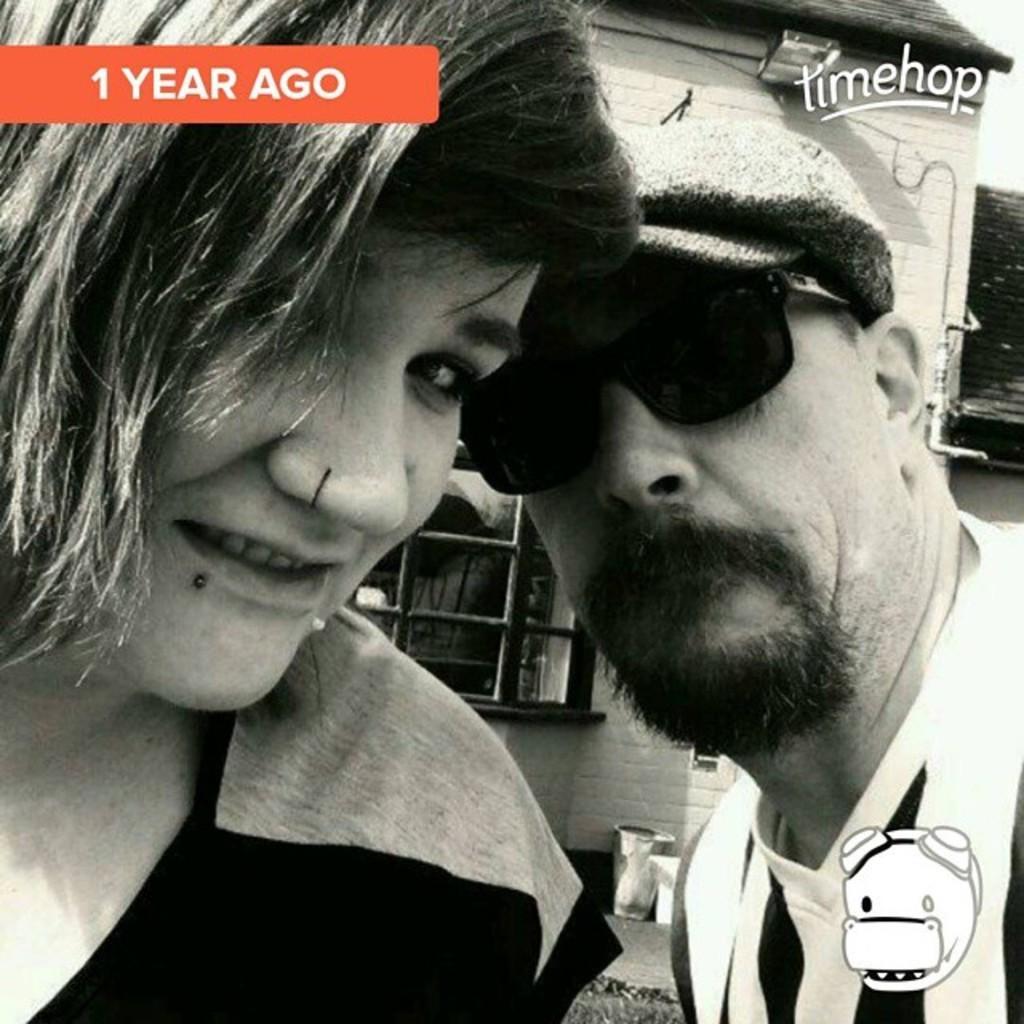Describe this image in one or two sentences. In this picture we can see a woman smiling and beside her a man wore goggles and at the back of them we can see a house with a window and some objects and stickers. 